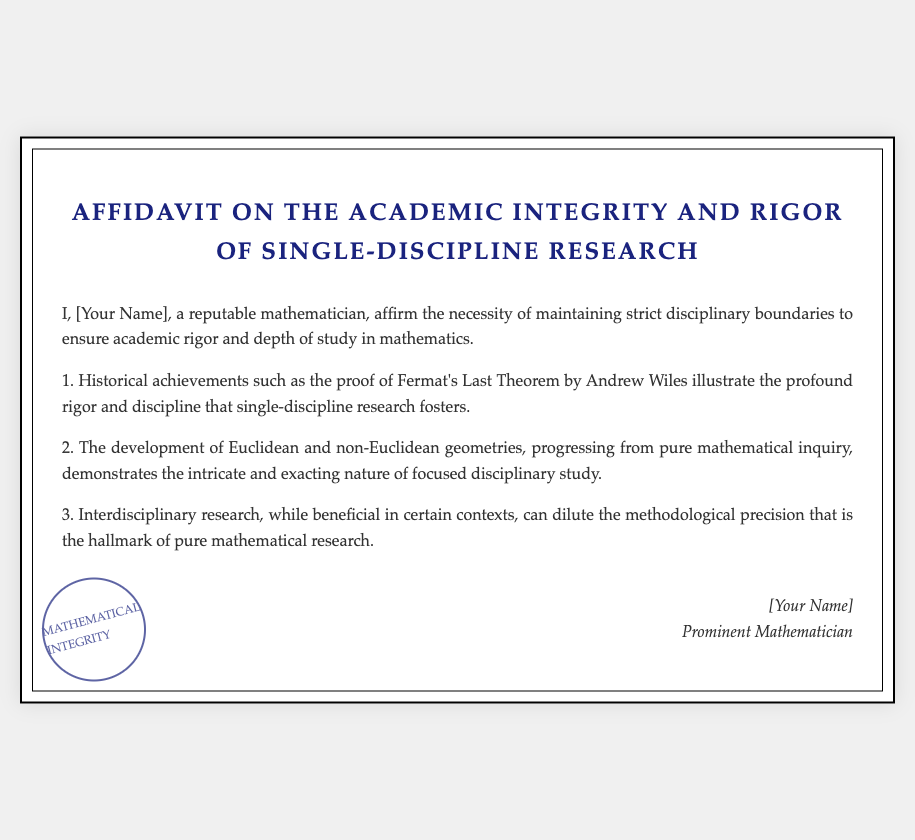What is the title of the document? The title is clearly stated at the top of the document, specifying the subject matter addressed.
Answer: Affidavit on the Academic Integrity and Rigor of Single-Discipline Research Who is the author of the affidavit? The author's name is mentioned in the introductory statement of the affidavit.
Answer: [Your Name] What historical achievement is cited in the affidavit? The affidavit references a specific achievement in mathematics to emphasize the point about disciplinary rigor.
Answer: Fermat's Last Theorem What does the affidavit claim about interdisciplinary research? A statement is provided in the document regarding the impact of interdisciplinary research on methodological precision.
Answer: Dilute the methodological precision What is emphasized as a benefit of single-discipline research in the affidavit? The document outlines a particular quality associated with rigorous mathematical inquiry.
Answer: Academic rigor and depth In what context does the affidavit discuss Euclidean and non-Euclidean geometries? It relates these geometries to the nature of study in mathematics and its focus.
Answer: Progressing from pure mathematical inquiry What visual element is included in the document to enhance its presentation? The document employs a visual feature that symbolizes authority and authenticity.
Answer: Seal What is the significance of the phrase "MATHEMATICAL INTEGRITY"? This phrase indicates the core value promoted by the affidavit concerning research practices.
Answer: Core value of the affidavit 